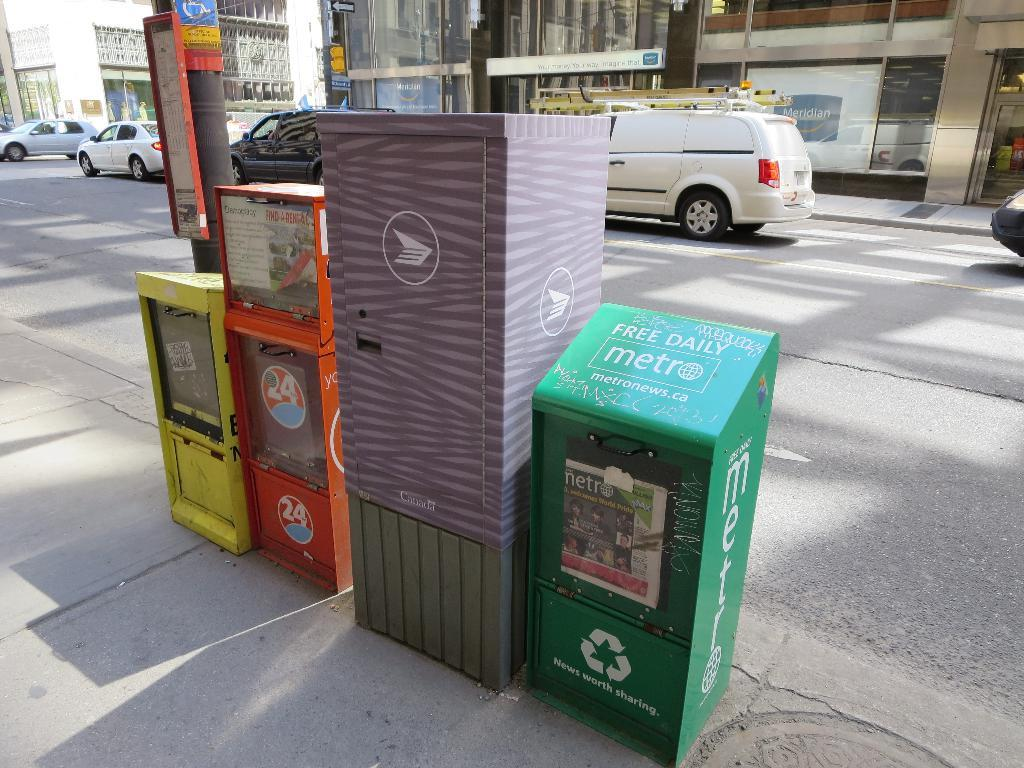What objects are located in the middle of the image? There are bins in the middle of the image. What can be seen in the background of the image? There are vehicles and buildings in the background of the image. What type of string is being used to hold up the tree in the image? There is no tree present in the image, so there is no string being used to hold it up. 